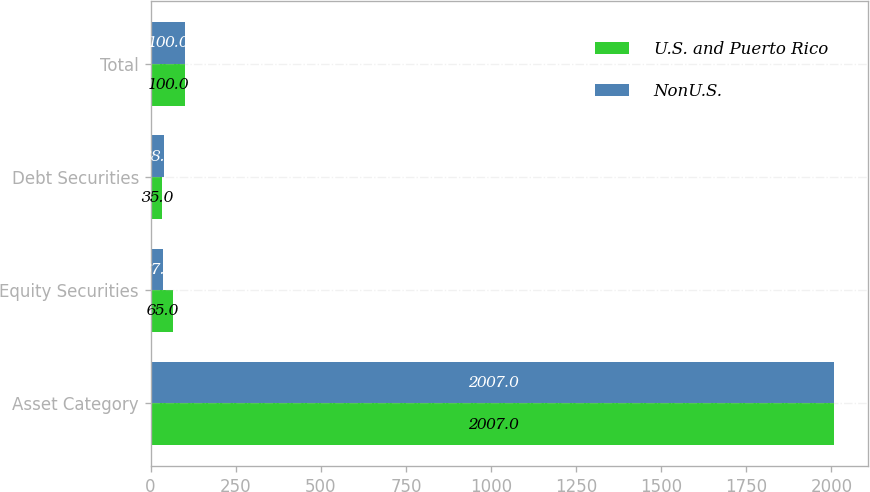Convert chart. <chart><loc_0><loc_0><loc_500><loc_500><stacked_bar_chart><ecel><fcel>Asset Category<fcel>Equity Securities<fcel>Debt Securities<fcel>Total<nl><fcel>U.S. and Puerto Rico<fcel>2007<fcel>65<fcel>35<fcel>100<nl><fcel>NonU.S.<fcel>2007<fcel>37<fcel>38<fcel>100<nl></chart> 